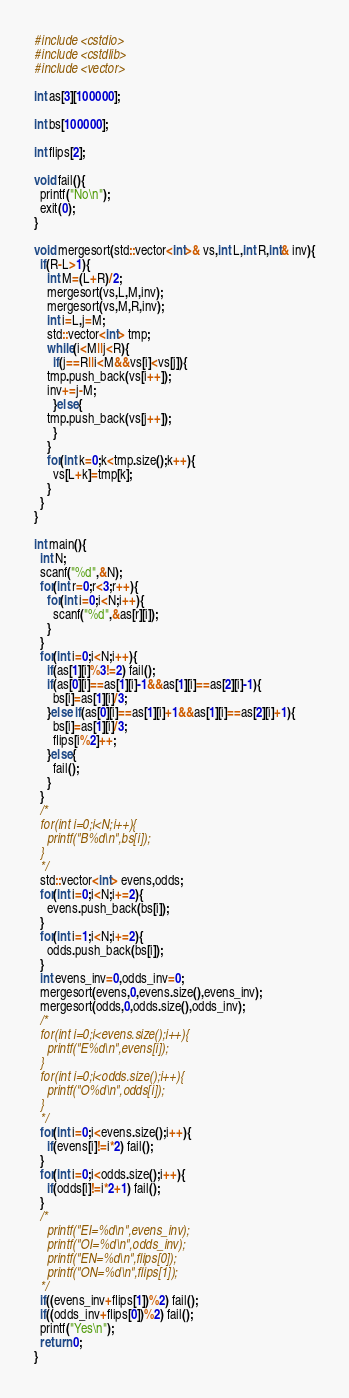Convert code to text. <code><loc_0><loc_0><loc_500><loc_500><_C++_>#include <cstdio>
#include <cstdlib>
#include <vector>

int as[3][100000];

int bs[100000];

int flips[2];

void fail(){
  printf("No\n");
  exit(0);
}

void mergesort(std::vector<int>& vs,int L,int R,int& inv){
  if(R-L>1){
    int M=(L+R)/2;
    mergesort(vs,L,M,inv);
    mergesort(vs,M,R,inv);
    int i=L,j=M;
    std::vector<int> tmp;
    while(i<M||j<R){
      if(j==R||i<M&&vs[i]<vs[j]){
	tmp.push_back(vs[i++]);
	inv+=j-M;
      }else{
	tmp.push_back(vs[j++]);
      }
    }
    for(int k=0;k<tmp.size();k++){
      vs[L+k]=tmp[k];
    }
  }
}

int main(){
  int N;
  scanf("%d",&N);
  for(int r=0;r<3;r++){
    for(int i=0;i<N;i++){
      scanf("%d",&as[r][i]);
    }
  }
  for(int i=0;i<N;i++){
    if(as[1][i]%3!=2) fail();
    if(as[0][i]==as[1][i]-1&&as[1][i]==as[2][i]-1){
      bs[i]=as[1][i]/3;
    }else if(as[0][i]==as[1][i]+1&&as[1][i]==as[2][i]+1){
      bs[i]=as[1][i]/3;
      flips[i%2]++;
    }else{
      fail();
    }
  }
  /*
  for(int i=0;i<N;i++){
    printf("B%d\n",bs[i]);
  }
  */
  std::vector<int> evens,odds;
  for(int i=0;i<N;i+=2){
    evens.push_back(bs[i]);
  }
  for(int i=1;i<N;i+=2){
    odds.push_back(bs[i]);
  }
  int evens_inv=0,odds_inv=0;
  mergesort(evens,0,evens.size(),evens_inv);
  mergesort(odds,0,odds.size(),odds_inv);
  /*
  for(int i=0;i<evens.size();i++){
    printf("E%d\n",evens[i]);
  }
  for(int i=0;i<odds.size();i++){
    printf("O%d\n",odds[i]);
  }
  */
  for(int i=0;i<evens.size();i++){
    if(evens[i]!=i*2) fail();
  }
  for(int i=0;i<odds.size();i++){
    if(odds[i]!=i*2+1) fail();
  }
  /*
    printf("EI=%d\n",evens_inv);
    printf("OI=%d\n",odds_inv);
    printf("EN=%d\n",flips[0]);
    printf("ON=%d\n",flips[1]);
  */
  if((evens_inv+flips[1])%2) fail();
  if((odds_inv+flips[0])%2) fail();
  printf("Yes\n");
  return 0;
}
</code> 